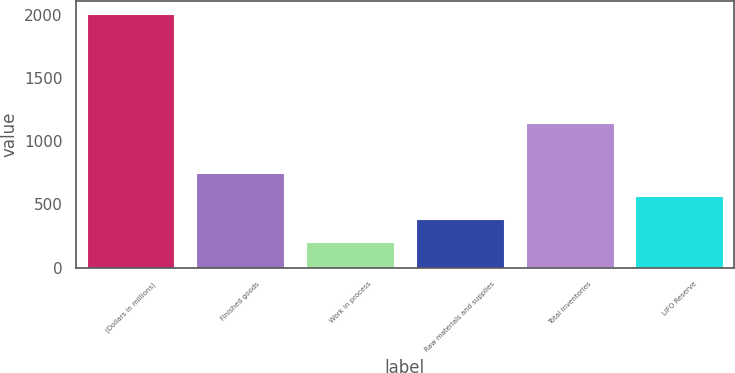Convert chart to OTSL. <chart><loc_0><loc_0><loc_500><loc_500><bar_chart><fcel>(Dollars in millions)<fcel>Finished goods<fcel>Work in process<fcel>Raw materials and supplies<fcel>Total inventories<fcel>LIFO Reserve<nl><fcel>2006<fcel>746<fcel>206<fcel>386<fcel>1146<fcel>566<nl></chart> 